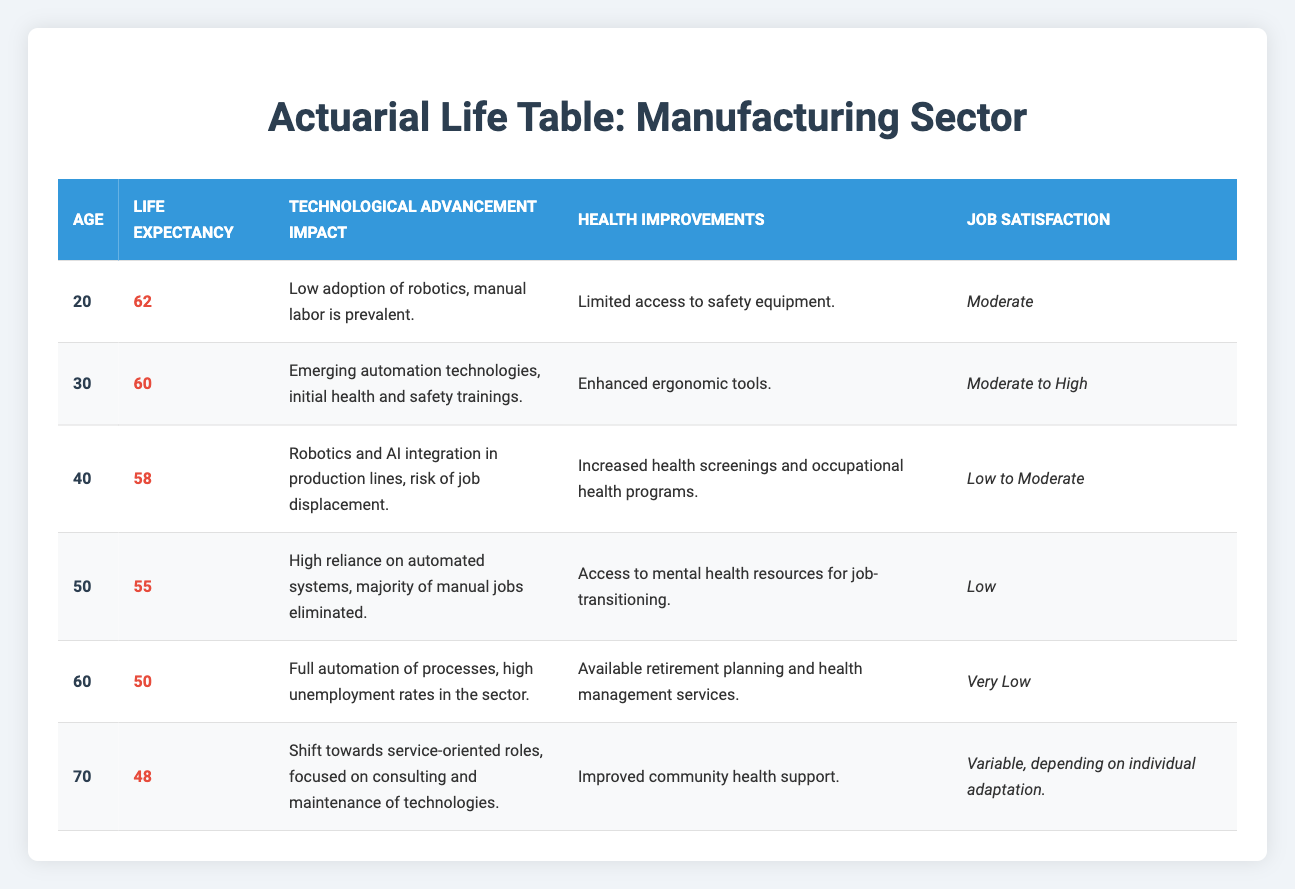What is the life expectancy for someone aged 40 in the manufacturing sector? The table indicates that the life expectancy for someone aged 40 is listed as 58 years. This information can be found directly in the Life Expectancy column corresponding to the Age Group of 40.
Answer: 58 What is the technological advancement impact for individuals aged 60? According to the table, individuals aged 60 experience full automation of processes, leading to high unemployment rates in the sector. This statement is found in the Technological Advancement Impact column for the age group of 60.
Answer: Full automation of processes, high unemployment rates How many life expectancy years are lost from age 20 to age 50? The life expectancy at age 20 is 62, while at age 50, it is 55. To find the number of years lost, we calculate the difference: 62 - 55 = 7 years. This arithmetic operation demonstrates the decline in life expectancy over that age span.
Answer: 7 Is job satisfaction rated as very low at age 60? The table shows that job satisfaction for individuals aged 60 is rated as very low. Therefore, this statement is true. This conclusion can be derived from the Job Satisfaction column for the age group of 60.
Answer: Yes What is the average life expectancy across all age groups in the table? To calculate the average life expectancy, we first sum the life expectancies: 62 + 60 + 58 + 55 + 50 + 48 = 333. Then, we divide this by the number of age groups, which is 6: 333 / 6 = 55.5. This process illustrates how to derive the average from the given data points.
Answer: 55.5 How does the job satisfaction change from age 30 to age 50? The job satisfaction for age 30 is rated as moderate to high, while for age 50 it is rated as low. This indicates a decline in job satisfaction as one ages within this range. This comparison can be made by looking at the corresponding Job Satisfaction values from the table for each age group.
Answer: Declines from moderate to high to low What improvements in health care are noted at age 40 compared to age 30? Age 40 mentions increased health screenings and occupational health programs, whereas age 30 highlights enhanced ergonomic tools. This denotes a shift in focus from ergonomic improvements to comprehensive health screenings at the age of 40. This analysis involves comparing the Health Improvements entries of age groups 30 and 40.
Answer: Increased health screenings vs. enhanced ergonomic tools Is the impact of technological advancement at age 70 focused on service-oriented roles? Yes, the information in the table states that at age 70 there is a shift towards service-oriented roles, specifically highlighting consulting and maintenance of technologies. This affirmation is backed by the Technological Advancement Impact entry for age 70.
Answer: Yes 